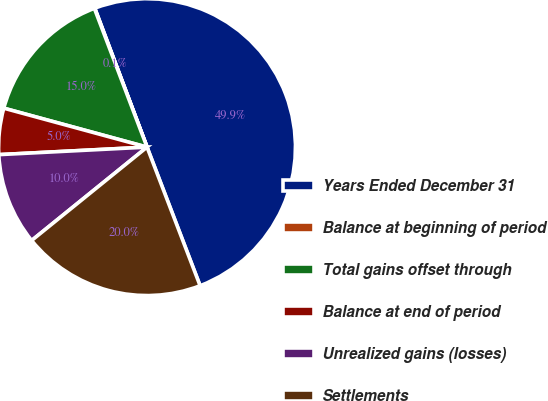Convert chart. <chart><loc_0><loc_0><loc_500><loc_500><pie_chart><fcel>Years Ended December 31<fcel>Balance at beginning of period<fcel>Total gains offset through<fcel>Balance at end of period<fcel>Unrealized gains (losses)<fcel>Settlements<nl><fcel>49.9%<fcel>0.05%<fcel>15.0%<fcel>5.03%<fcel>10.02%<fcel>19.99%<nl></chart> 